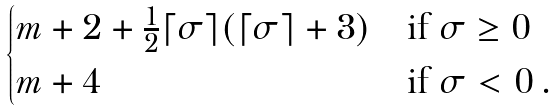<formula> <loc_0><loc_0><loc_500><loc_500>\begin{cases} m + 2 + \frac { 1 } { 2 } \lceil \sigma \rceil ( \lceil \sigma \rceil + 3 ) & \text {if $\sigma\geq0$} \\ m + 4 & \text {if $\sigma<0$} \, . \end{cases}</formula> 